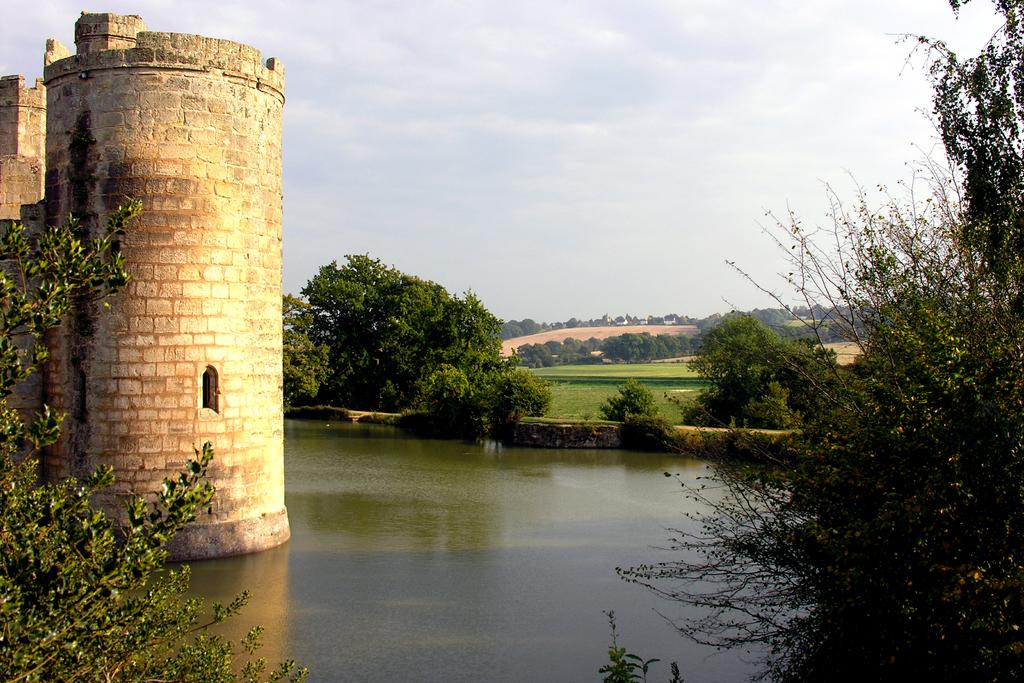What is the primary element visible in the image? There is water in the image. What can be seen near the water? There are many trees to the side of the water. What type of structure is visible in the image? There is a fort visible in the image. What is visible in the background of the image? There are more trees and clouds in the background of the image. What part of the sky is visible in the image? The sky is visible in the background of the image. What type of scent can be smelled coming from the protest in the image? There is no protest present in the image, so no scent can be associated with it. 